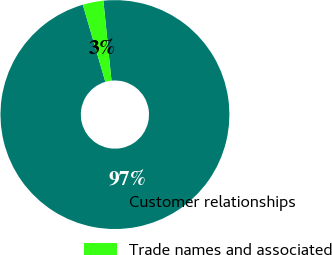Convert chart. <chart><loc_0><loc_0><loc_500><loc_500><pie_chart><fcel>Customer relationships<fcel>Trade names and associated<nl><fcel>97.08%<fcel>2.92%<nl></chart> 